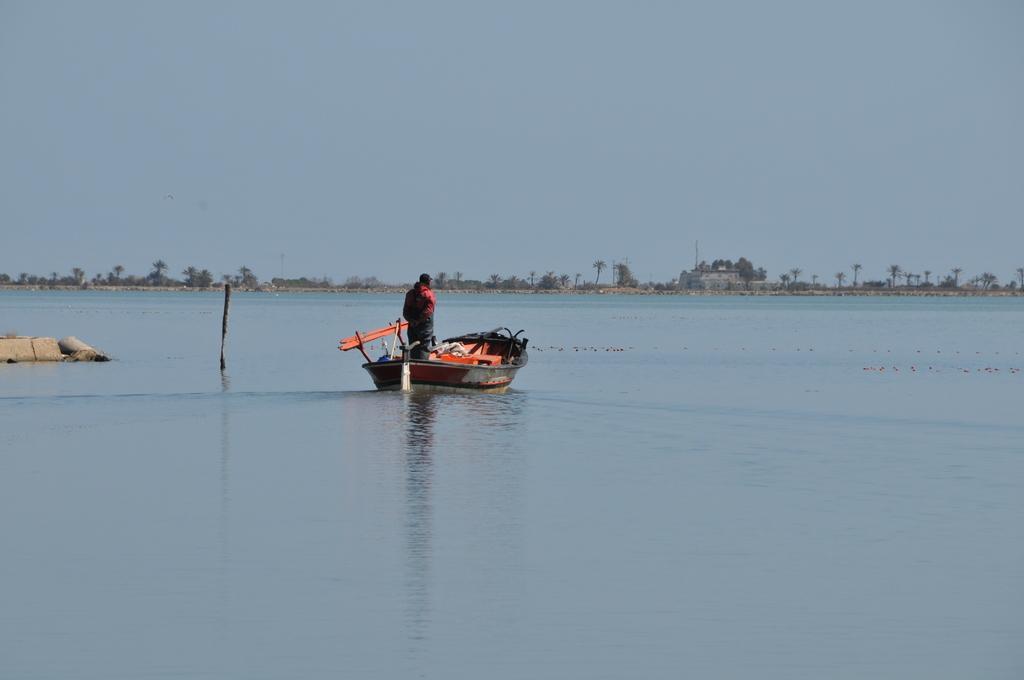Could you give a brief overview of what you see in this image? In this image we can see a person standing on the boat, water, trees, buildings and sky. 